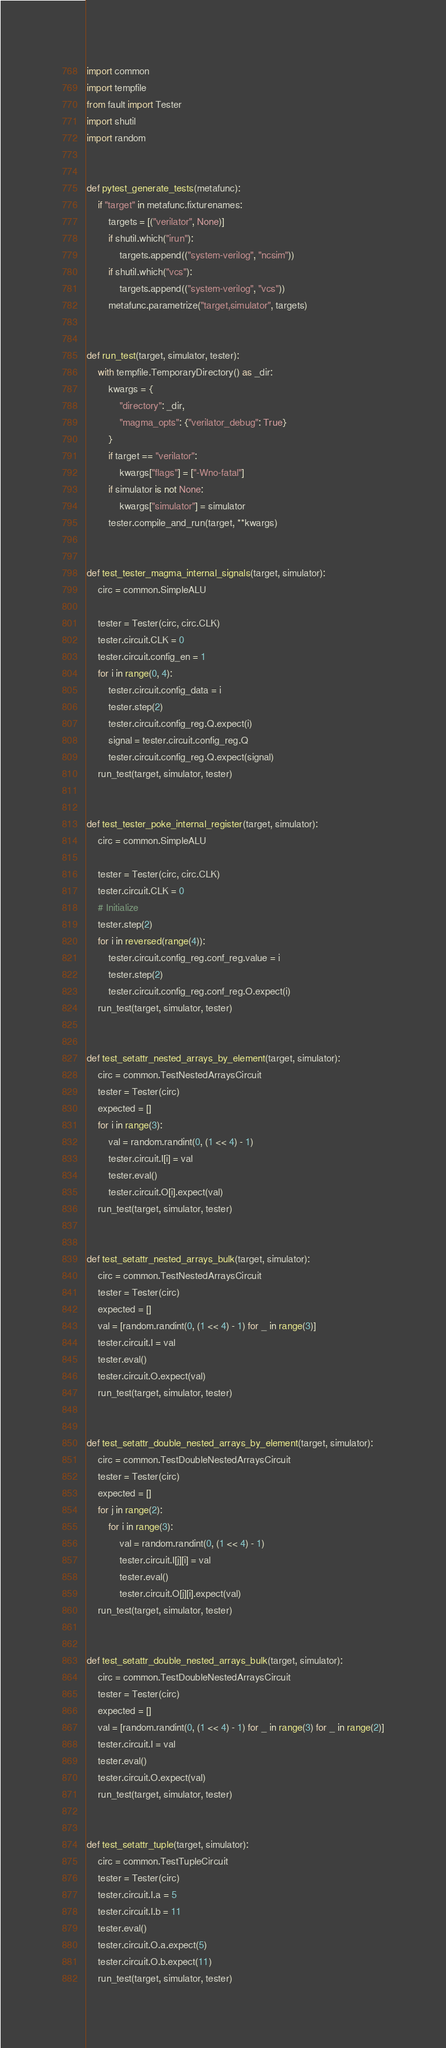Convert code to text. <code><loc_0><loc_0><loc_500><loc_500><_Python_>import common
import tempfile
from fault import Tester
import shutil
import random


def pytest_generate_tests(metafunc):
    if "target" in metafunc.fixturenames:
        targets = [("verilator", None)]
        if shutil.which("irun"):
            targets.append(("system-verilog", "ncsim"))
        if shutil.which("vcs"):
            targets.append(("system-verilog", "vcs"))
        metafunc.parametrize("target,simulator", targets)


def run_test(target, simulator, tester):
    with tempfile.TemporaryDirectory() as _dir:
        kwargs = {
            "directory": _dir,
            "magma_opts": {"verilator_debug": True}
        }
        if target == "verilator":
            kwargs["flags"] = ["-Wno-fatal"]
        if simulator is not None:
            kwargs["simulator"] = simulator
        tester.compile_and_run(target, **kwargs)


def test_tester_magma_internal_signals(target, simulator):
    circ = common.SimpleALU

    tester = Tester(circ, circ.CLK)
    tester.circuit.CLK = 0
    tester.circuit.config_en = 1
    for i in range(0, 4):
        tester.circuit.config_data = i
        tester.step(2)
        tester.circuit.config_reg.Q.expect(i)
        signal = tester.circuit.config_reg.Q
        tester.circuit.config_reg.Q.expect(signal)
    run_test(target, simulator, tester)


def test_tester_poke_internal_register(target, simulator):
    circ = common.SimpleALU

    tester = Tester(circ, circ.CLK)
    tester.circuit.CLK = 0
    # Initialize
    tester.step(2)
    for i in reversed(range(4)):
        tester.circuit.config_reg.conf_reg.value = i
        tester.step(2)
        tester.circuit.config_reg.conf_reg.O.expect(i)
    run_test(target, simulator, tester)


def test_setattr_nested_arrays_by_element(target, simulator):
    circ = common.TestNestedArraysCircuit
    tester = Tester(circ)
    expected = []
    for i in range(3):
        val = random.randint(0, (1 << 4) - 1)
        tester.circuit.I[i] = val
        tester.eval()
        tester.circuit.O[i].expect(val)
    run_test(target, simulator, tester)


def test_setattr_nested_arrays_bulk(target, simulator):
    circ = common.TestNestedArraysCircuit
    tester = Tester(circ)
    expected = []
    val = [random.randint(0, (1 << 4) - 1) for _ in range(3)]
    tester.circuit.I = val
    tester.eval()
    tester.circuit.O.expect(val)
    run_test(target, simulator, tester)


def test_setattr_double_nested_arrays_by_element(target, simulator):
    circ = common.TestDoubleNestedArraysCircuit
    tester = Tester(circ)
    expected = []
    for j in range(2):
        for i in range(3):
            val = random.randint(0, (1 << 4) - 1)
            tester.circuit.I[j][i] = val
            tester.eval()
            tester.circuit.O[j][i].expect(val)
    run_test(target, simulator, tester)


def test_setattr_double_nested_arrays_bulk(target, simulator):
    circ = common.TestDoubleNestedArraysCircuit
    tester = Tester(circ)
    expected = []
    val = [random.randint(0, (1 << 4) - 1) for _ in range(3) for _ in range(2)]
    tester.circuit.I = val
    tester.eval()
    tester.circuit.O.expect(val)
    run_test(target, simulator, tester)


def test_setattr_tuple(target, simulator):
    circ = common.TestTupleCircuit
    tester = Tester(circ)
    tester.circuit.I.a = 5
    tester.circuit.I.b = 11
    tester.eval()
    tester.circuit.O.a.expect(5)
    tester.circuit.O.b.expect(11)
    run_test(target, simulator, tester)
</code> 